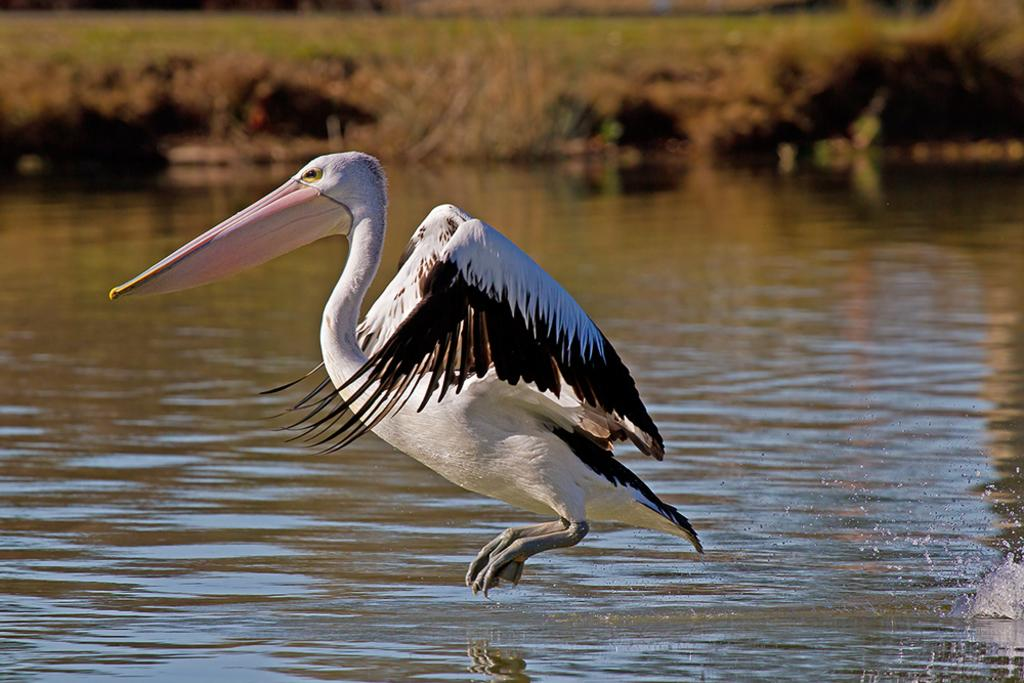What type of animal can be seen in the image? There is a bird in the image. What is the primary element in which the bird is situated? There is water visible in the image, and the bird is likely situated in or near it. What other living organisms can be seen in the image? There are plants in the image. What type of jar is the bird using to communicate with its partner in the image? There is no jar present in the image, and the bird is not shown communicating with a partner. 